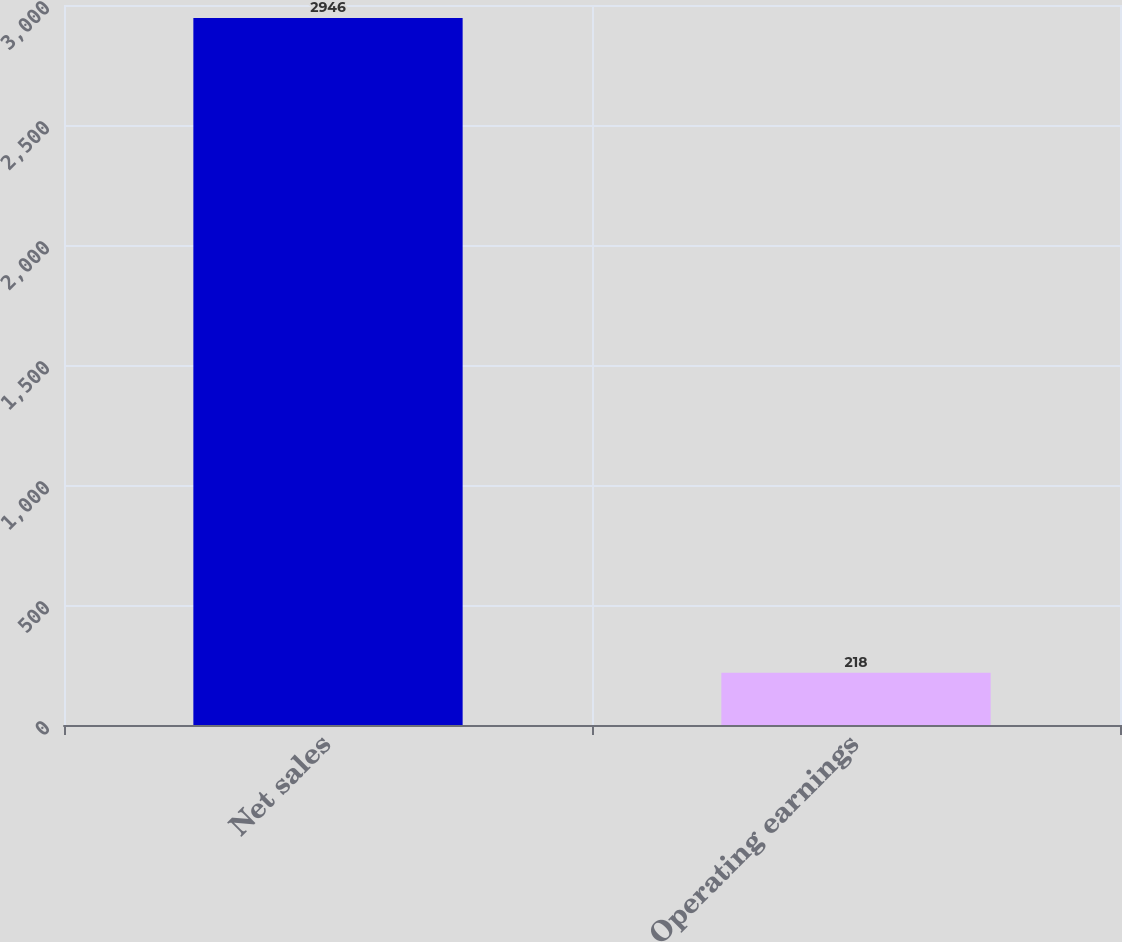Convert chart. <chart><loc_0><loc_0><loc_500><loc_500><bar_chart><fcel>Net sales<fcel>Operating earnings<nl><fcel>2946<fcel>218<nl></chart> 